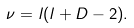Convert formula to latex. <formula><loc_0><loc_0><loc_500><loc_500>\nu = l ( l + D - 2 ) .</formula> 